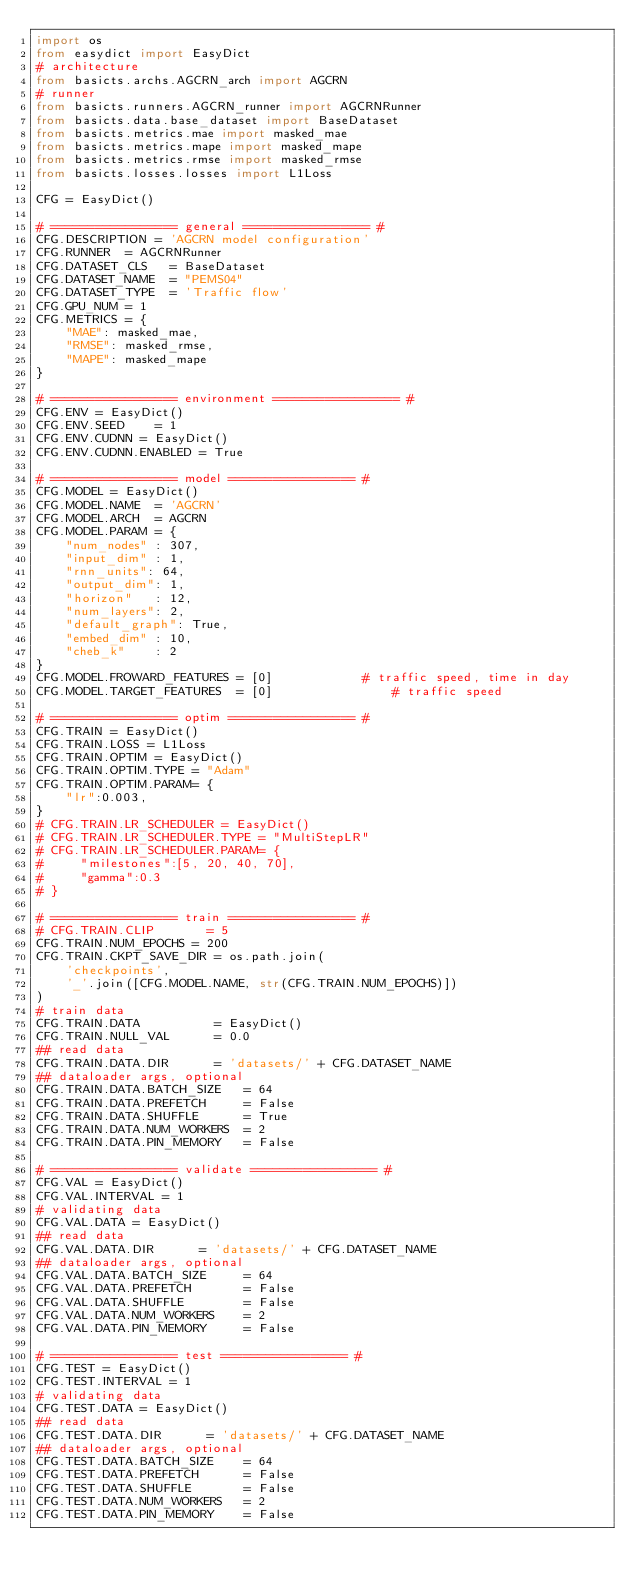Convert code to text. <code><loc_0><loc_0><loc_500><loc_500><_Python_>import os
from easydict import EasyDict
# architecture 
from basicts.archs.AGCRN_arch import AGCRN
# runner
from basicts.runners.AGCRN_runner import AGCRNRunner
from basicts.data.base_dataset import BaseDataset
from basicts.metrics.mae import masked_mae
from basicts.metrics.mape import masked_mape
from basicts.metrics.rmse import masked_rmse
from basicts.losses.losses import L1Loss

CFG = EasyDict()

# ================= general ================= #
CFG.DESCRIPTION = 'AGCRN model configuration'
CFG.RUNNER  = AGCRNRunner
CFG.DATASET_CLS   = BaseDataset
CFG.DATASET_NAME  = "PEMS04"
CFG.DATASET_TYPE  = 'Traffic flow'
CFG.GPU_NUM = 1
CFG.METRICS = {
    "MAE": masked_mae,
    "RMSE": masked_rmse,
    "MAPE": masked_mape
}

# ================= environment ================= #
CFG.ENV = EasyDict()
CFG.ENV.SEED    = 1
CFG.ENV.CUDNN = EasyDict()
CFG.ENV.CUDNN.ENABLED = True

# ================= model ================= #
CFG.MODEL = EasyDict()
CFG.MODEL.NAME  = 'AGCRN'
CFG.MODEL.ARCH  = AGCRN
CFG.MODEL.PARAM = {
    "num_nodes" : 307, 
    "input_dim" : 1,
    "rnn_units": 64,
    "output_dim": 1,
    "horizon"   : 12,
    "num_layers": 2,
    "default_graph": True,
    "embed_dim" : 10,
    "cheb_k"    : 2
}
CFG.MODEL.FROWARD_FEATURES = [0]            # traffic speed, time in day
CFG.MODEL.TARGET_FEATURES  = [0]                # traffic speed

# ================= optim ================= #
CFG.TRAIN = EasyDict()
CFG.TRAIN.LOSS = L1Loss
CFG.TRAIN.OPTIM = EasyDict()
CFG.TRAIN.OPTIM.TYPE = "Adam"
CFG.TRAIN.OPTIM.PARAM= {
    "lr":0.003,
}
# CFG.TRAIN.LR_SCHEDULER = EasyDict()
# CFG.TRAIN.LR_SCHEDULER.TYPE = "MultiStepLR"
# CFG.TRAIN.LR_SCHEDULER.PARAM= {
#     "milestones":[5, 20, 40, 70],
#     "gamma":0.3
# }

# ================= train ================= #
# CFG.TRAIN.CLIP       = 5
CFG.TRAIN.NUM_EPOCHS = 200
CFG.TRAIN.CKPT_SAVE_DIR = os.path.join(
    'checkpoints',
    '_'.join([CFG.MODEL.NAME, str(CFG.TRAIN.NUM_EPOCHS)])
)
# train data
CFG.TRAIN.DATA          = EasyDict()
CFG.TRAIN.NULL_VAL      = 0.0
## read data
CFG.TRAIN.DATA.DIR      = 'datasets/' + CFG.DATASET_NAME
## dataloader args, optional
CFG.TRAIN.DATA.BATCH_SIZE   = 64
CFG.TRAIN.DATA.PREFETCH     = False
CFG.TRAIN.DATA.SHUFFLE      = True
CFG.TRAIN.DATA.NUM_WORKERS  = 2
CFG.TRAIN.DATA.PIN_MEMORY   = False

# ================= validate ================= #
CFG.VAL = EasyDict()
CFG.VAL.INTERVAL = 1
# validating data
CFG.VAL.DATA = EasyDict()
## read data
CFG.VAL.DATA.DIR      = 'datasets/' + CFG.DATASET_NAME
## dataloader args, optional
CFG.VAL.DATA.BATCH_SIZE     = 64
CFG.VAL.DATA.PREFETCH       = False
CFG.VAL.DATA.SHUFFLE        = False
CFG.VAL.DATA.NUM_WORKERS    = 2
CFG.VAL.DATA.PIN_MEMORY     = False

# ================= test ================= #
CFG.TEST = EasyDict()
CFG.TEST.INTERVAL = 1
# validating data
CFG.TEST.DATA = EasyDict()
## read data
CFG.TEST.DATA.DIR      = 'datasets/' + CFG.DATASET_NAME
## dataloader args, optional
CFG.TEST.DATA.BATCH_SIZE    = 64
CFG.TEST.DATA.PREFETCH      = False
CFG.TEST.DATA.SHUFFLE       = False
CFG.TEST.DATA.NUM_WORKERS   = 2
CFG.TEST.DATA.PIN_MEMORY    = False
</code> 